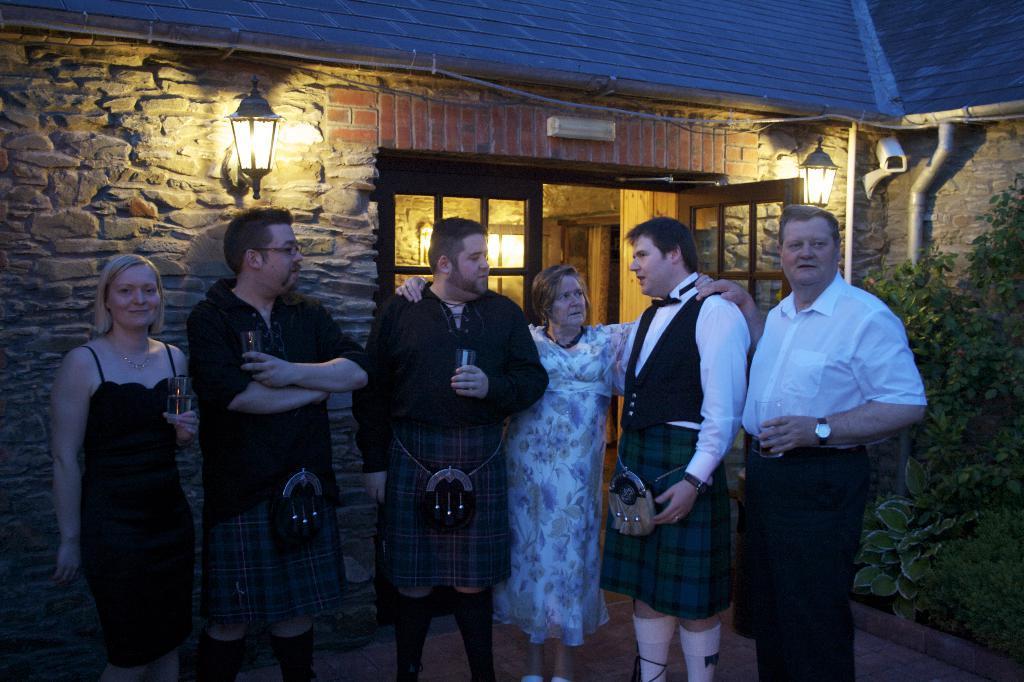Describe this image in one or two sentences. In the middle of the picture we can see a group of people standing. In the background it is a building and there are door, wall, light, camera, tree, pipe and other objects. 